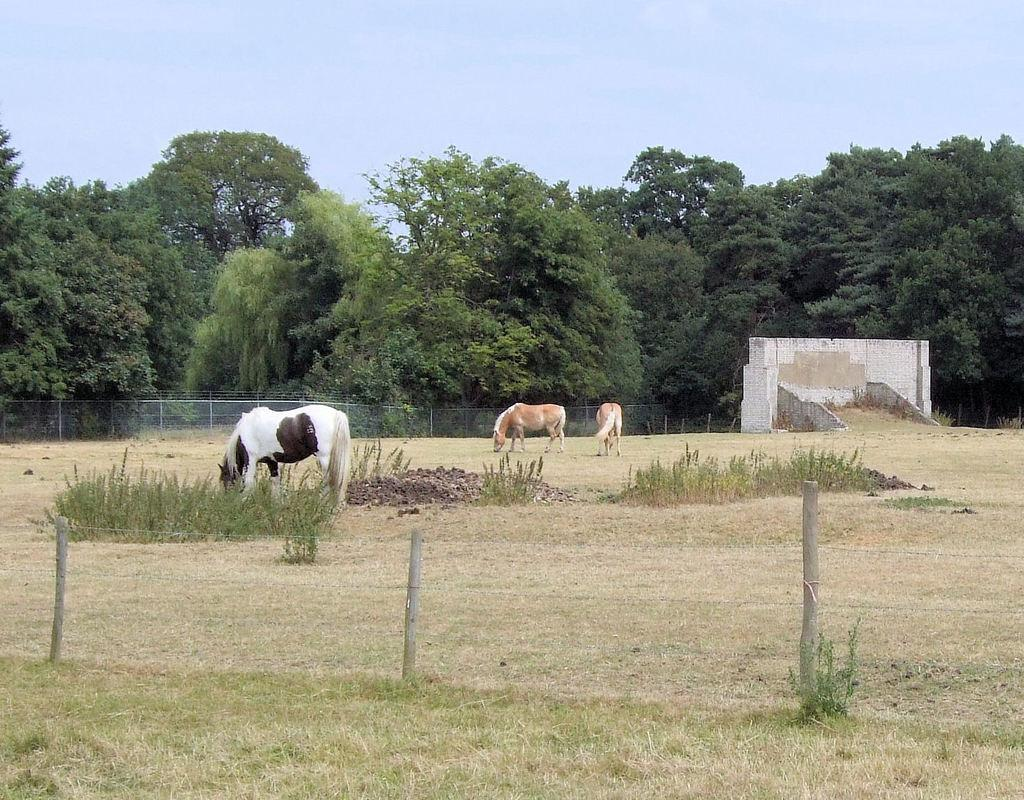What types of living organisms can be seen in the image? There are animals in the image. What natural elements are present in the image? There are trees and plants on the ground in the image. What man-made structures can be seen in the image? There is a fence, poles, and a wall in the image. What type of sheet is being used by the beggar in the image? There is no beggar present in the image, and therefore no sheet being used. What idea is being discussed by the animals in the image? The image does not depict any ideas being discussed; it simply shows animals, trees, and other elements. 